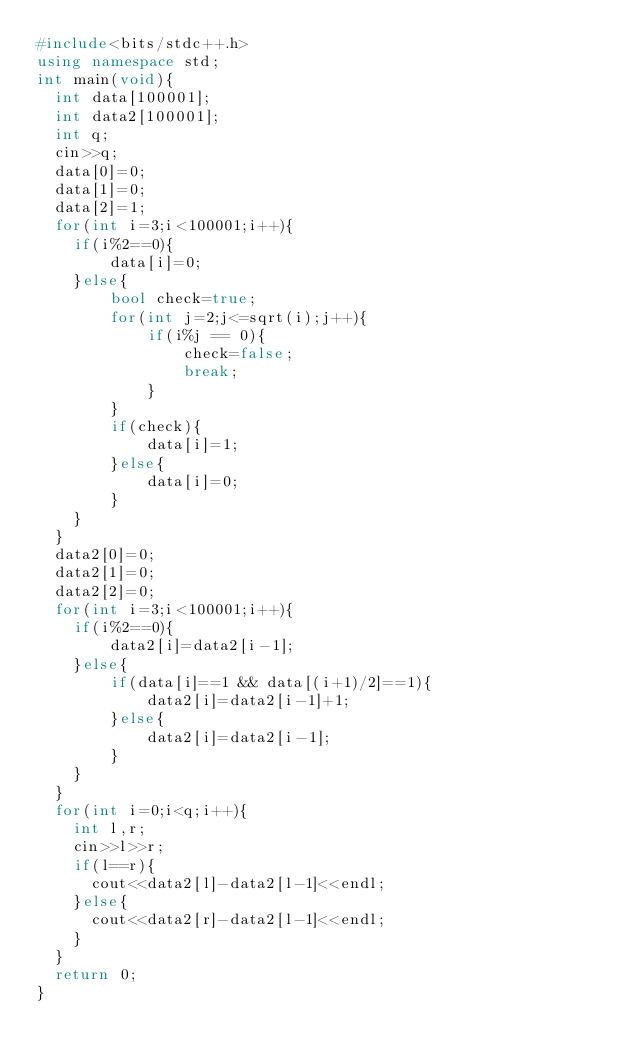<code> <loc_0><loc_0><loc_500><loc_500><_C++_>#include<bits/stdc++.h>
using namespace std;
int main(void){
  int data[100001];
  int data2[100001];
  int q;
  cin>>q;
  data[0]=0;
  data[1]=0;
  data[2]=1;
  for(int i=3;i<100001;i++){
  	if(i%2==0){
  		data[i]=0;
  	}else{
  	    bool check=true;
  		for(int j=2;j<=sqrt(i);j++){
  			if(i%j == 0){
  				check=false;
  				break;
  			}
  		}
  		if(check){
  			data[i]=1;
  		}else{
  			data[i]=0;
  		}
  	}
  }
  data2[0]=0;
  data2[1]=0;
  data2[2]=0;
  for(int i=3;i<100001;i++){
  	if(i%2==0){
  		data2[i]=data2[i-1];
  	}else{
  		if(data[i]==1 && data[(i+1)/2]==1){
  			data2[i]=data2[i-1]+1;
  		}else{
  			data2[i]=data2[i-1];
  		}
  	}
  }
  for(int i=0;i<q;i++){
  	int l,r;
  	cin>>l>>r;
  	if(l==r){
  	  cout<<data2[l]-data2[l-1]<<endl;
  	}else{
  	  cout<<data2[r]-data2[l-1]<<endl;
  	}
  }
  return 0;
}</code> 